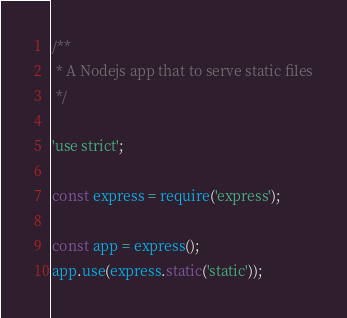<code> <loc_0><loc_0><loc_500><loc_500><_JavaScript_>
/**
 * A Nodejs app that to serve static files
 */

'use strict';

const express = require('express');

const app = express();
app.use(express.static('static'));</code> 